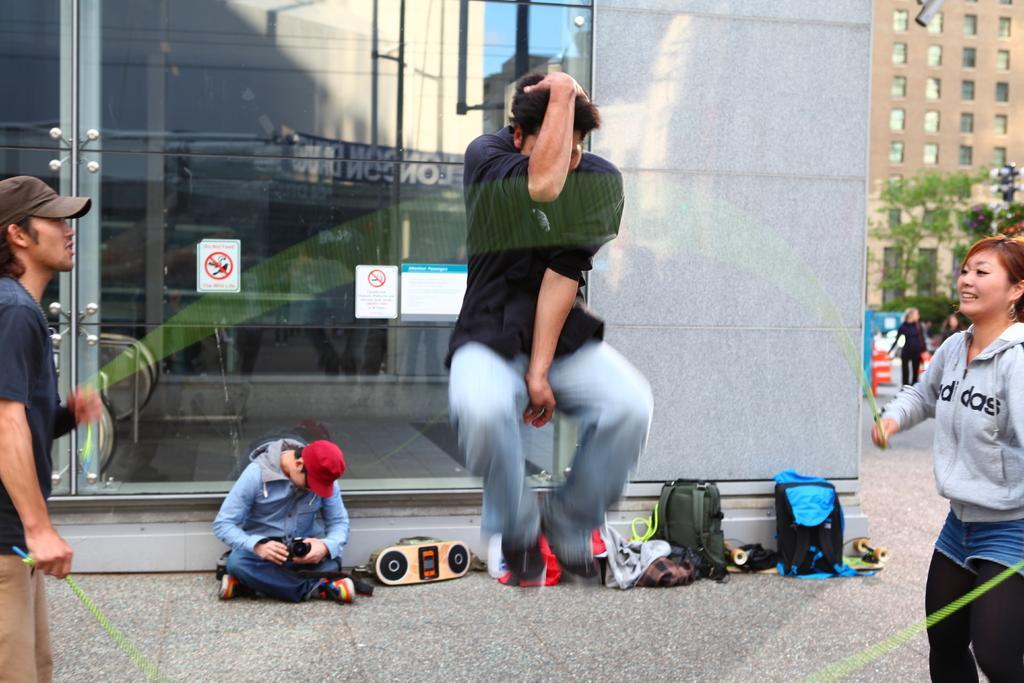Could you give a brief overview of what you see in this image? In the foreground I can see a person is jumping in the air and two persons are holding a rope in hand. In the background I can see a person is sitting on the road, some objects, bags, buildings, glass, boards, shops, windows, trees, light poles, stoppers, group of people on the road and the sky. This image is taken may be during a day. 